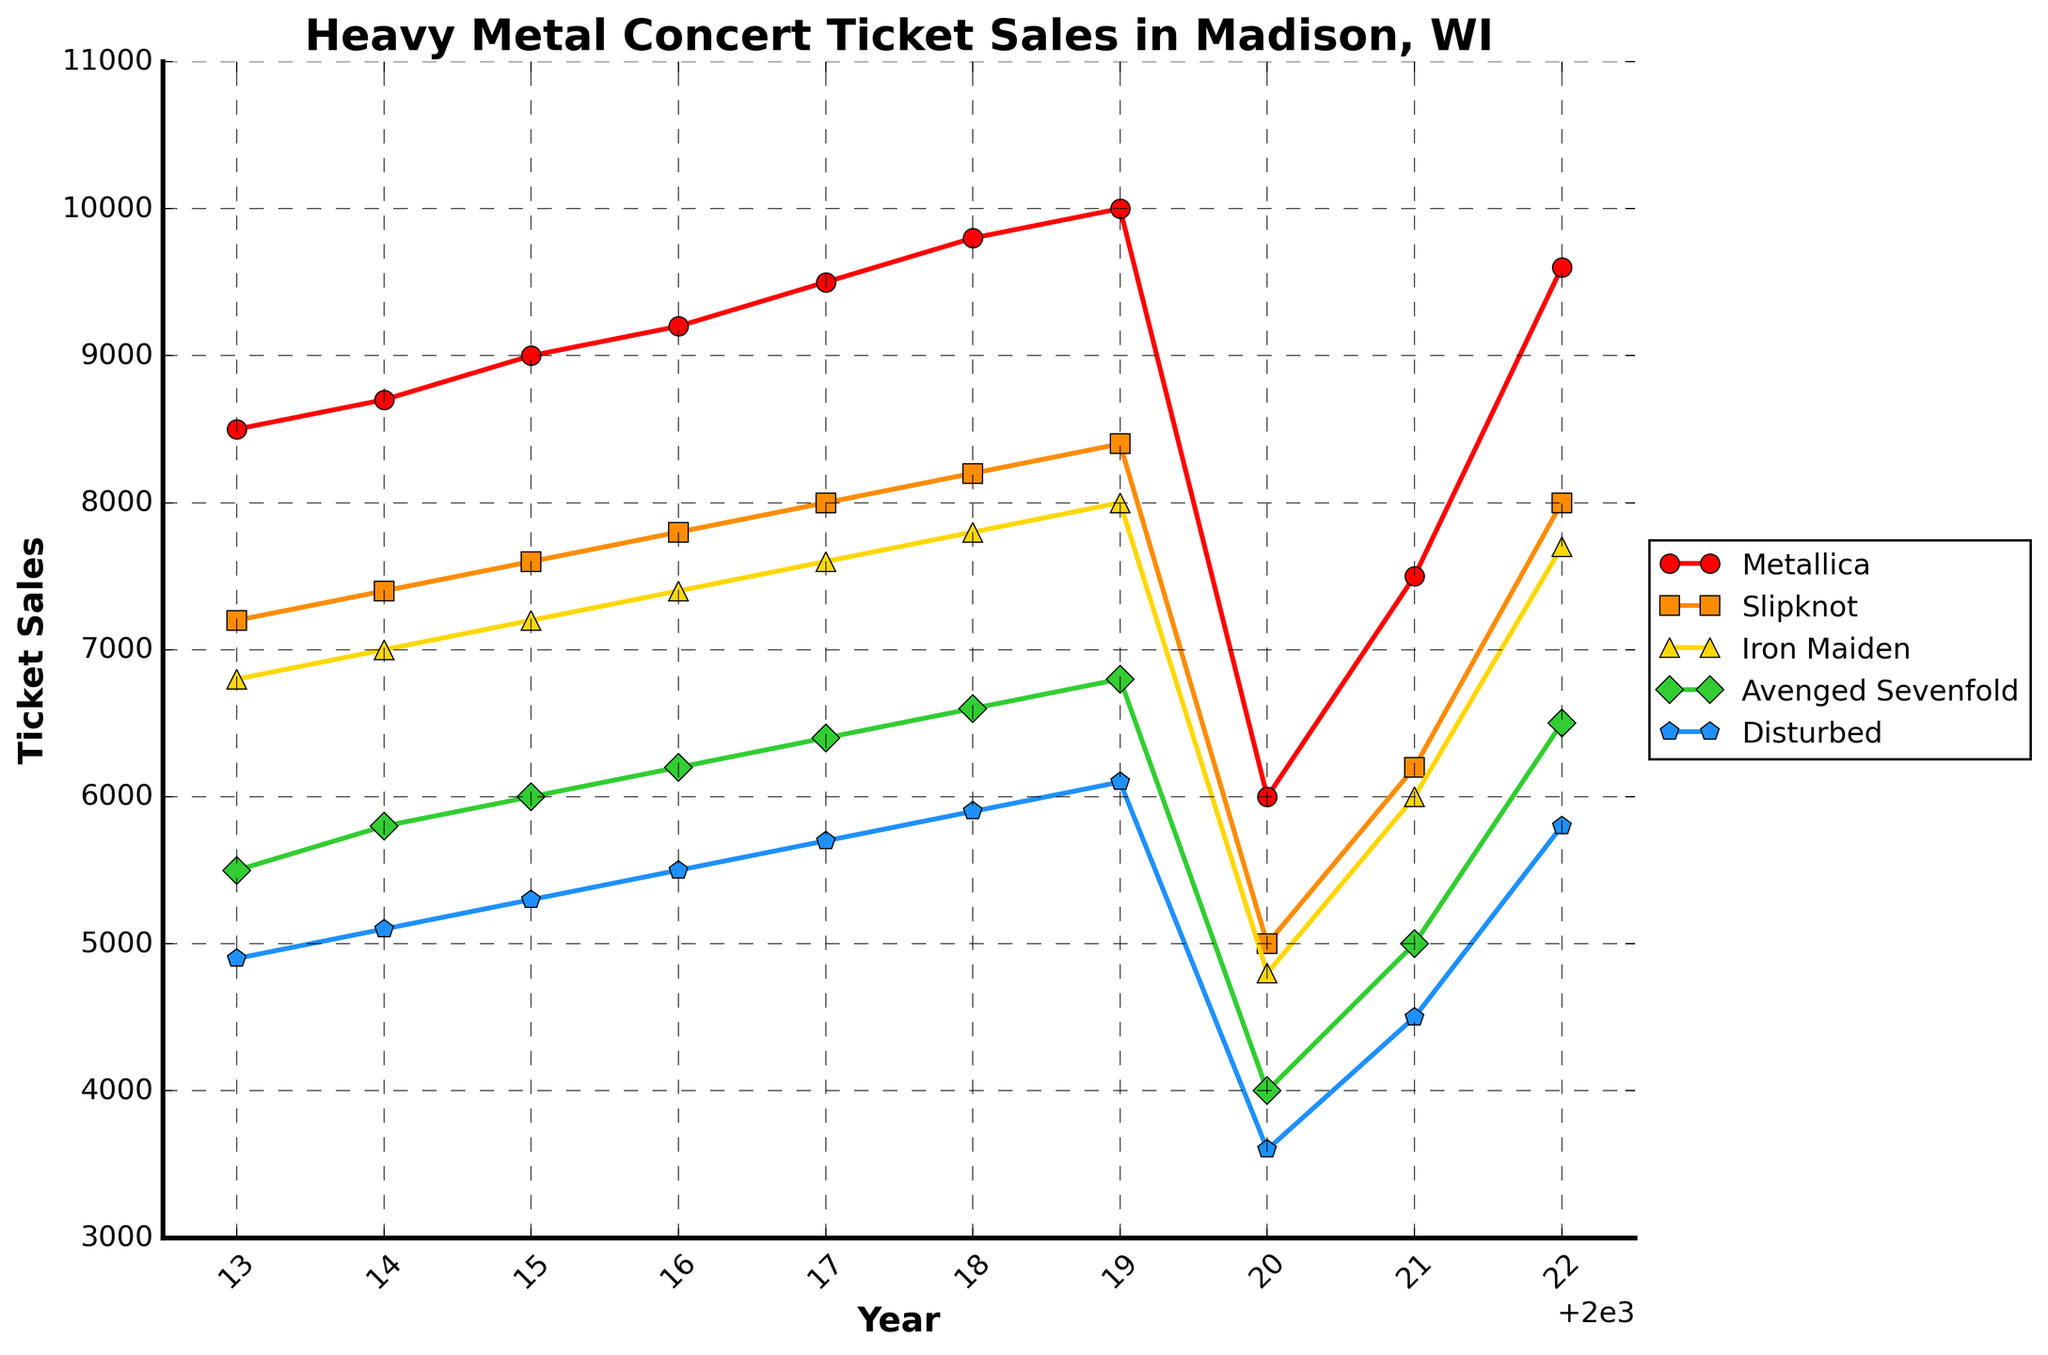Which band had the highest ticket sales in 2019? Look at the 2019 data for each band. The highest point is at 10000 tickets for Metallica.
Answer: Metallica Which years did Avenged Sevenfold see an increase in ticket sales? Identify the points for Avenged Sevenfold and compare each consecutive year from 2013 to 2022. Sales increased every year except 2020 and 2021.
Answer: 2013, 2014, 2015, 2016, 2017, 2018, 2019, 2022 What is the average ticket sales for Iron Maiden from 2017 to 2019? Sum Iron Maiden's ticket sales from 2017 to 2019 (7600, 7800, 8000) and divide by 3. Calculation: (7600 + 7800 + 8000) / 3 = 7800
Answer: 7800 Which band experienced the largest drop in ticket sales from 2019 to 2020? Calculate the difference in ticket sales for each band from 2019 to 2020. Metallica had the biggest drop from 10000 to 6000, a difference of 4000.
Answer: Metallica By how much did Slipknot’s ticket sales change in 2022 compared to 2021? Subtract Slipknot's ticket sales in 2021 from that in 2022. Calculation: 8000 - 6200 = 1800
Answer: 1800 Which band had the lowest ticket sales in 2020? Look at the 2020 data for each band. The lowest point is at 3600 tickets for Disturbed.
Answer: Disturbed Which band(s) surpassed 9000 ticket sales multiple times throughout the decade? Look up every instance where a band's ticket sales are above 9000. Only Metallica had ticket sales above 9000 from 2017, 2018, 2019, and 2022.
Answer: Metallica How does the trend in ticket sales for Disturbed compare to Avenged Sevenfold over the entire period shown? Observe the entire period from 2013 to 2022 for both bands. Disturbed generally increases but at a lower range, while Avenged Sevenfold has a steeper increase and higher range.
Answer: Avenged Sevenfold had a stronger upward trend 